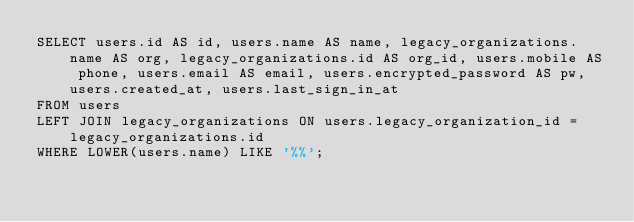<code> <loc_0><loc_0><loc_500><loc_500><_SQL_>SELECT users.id AS id, users.name AS name, legacy_organizations.name AS org, legacy_organizations.id AS org_id, users.mobile AS phone, users.email AS email, users.encrypted_password AS pw, users.created_at, users.last_sign_in_at
FROM users 
LEFT JOIN legacy_organizations ON users.legacy_organization_id = legacy_organizations.id
WHERE LOWER(users.name) LIKE '%%';</code> 